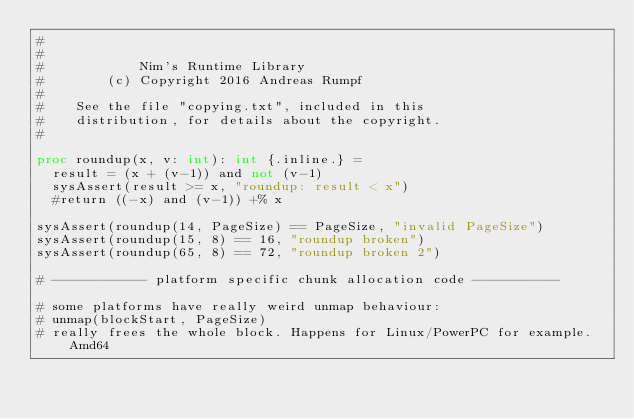<code> <loc_0><loc_0><loc_500><loc_500><_Nim_>#
#
#            Nim's Runtime Library
#        (c) Copyright 2016 Andreas Rumpf
#
#    See the file "copying.txt", included in this
#    distribution, for details about the copyright.
#

proc roundup(x, v: int): int {.inline.} =
  result = (x + (v-1)) and not (v-1)
  sysAssert(result >= x, "roundup: result < x")
  #return ((-x) and (v-1)) +% x

sysAssert(roundup(14, PageSize) == PageSize, "invalid PageSize")
sysAssert(roundup(15, 8) == 16, "roundup broken")
sysAssert(roundup(65, 8) == 72, "roundup broken 2")

# ------------ platform specific chunk allocation code -----------

# some platforms have really weird unmap behaviour:
# unmap(blockStart, PageSize)
# really frees the whole block. Happens for Linux/PowerPC for example. Amd64</code> 